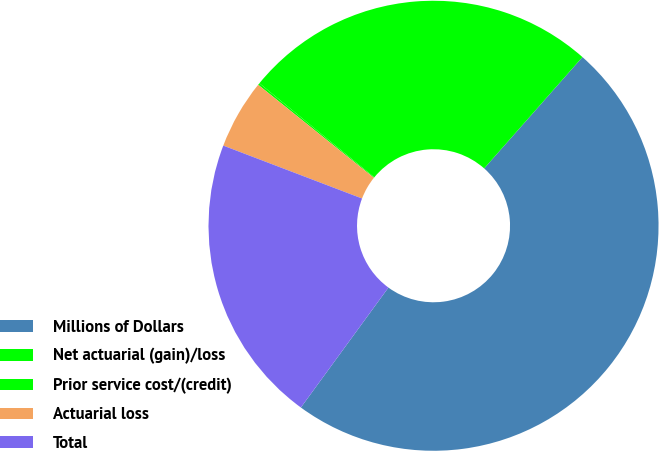<chart> <loc_0><loc_0><loc_500><loc_500><pie_chart><fcel>Millions of Dollars<fcel>Net actuarial (gain)/loss<fcel>Prior service cost/(credit)<fcel>Actuarial loss<fcel>Total<nl><fcel>48.52%<fcel>25.59%<fcel>0.14%<fcel>4.98%<fcel>20.76%<nl></chart> 